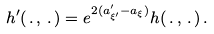Convert formula to latex. <formula><loc_0><loc_0><loc_500><loc_500>h ^ { \prime } ( \, . \, , \, . \, ) = e ^ { 2 ( a ^ { \prime } _ { \xi ^ { \prime } } - a _ { \xi } ) } h ( \, . \, , \, . \, ) \, .</formula> 